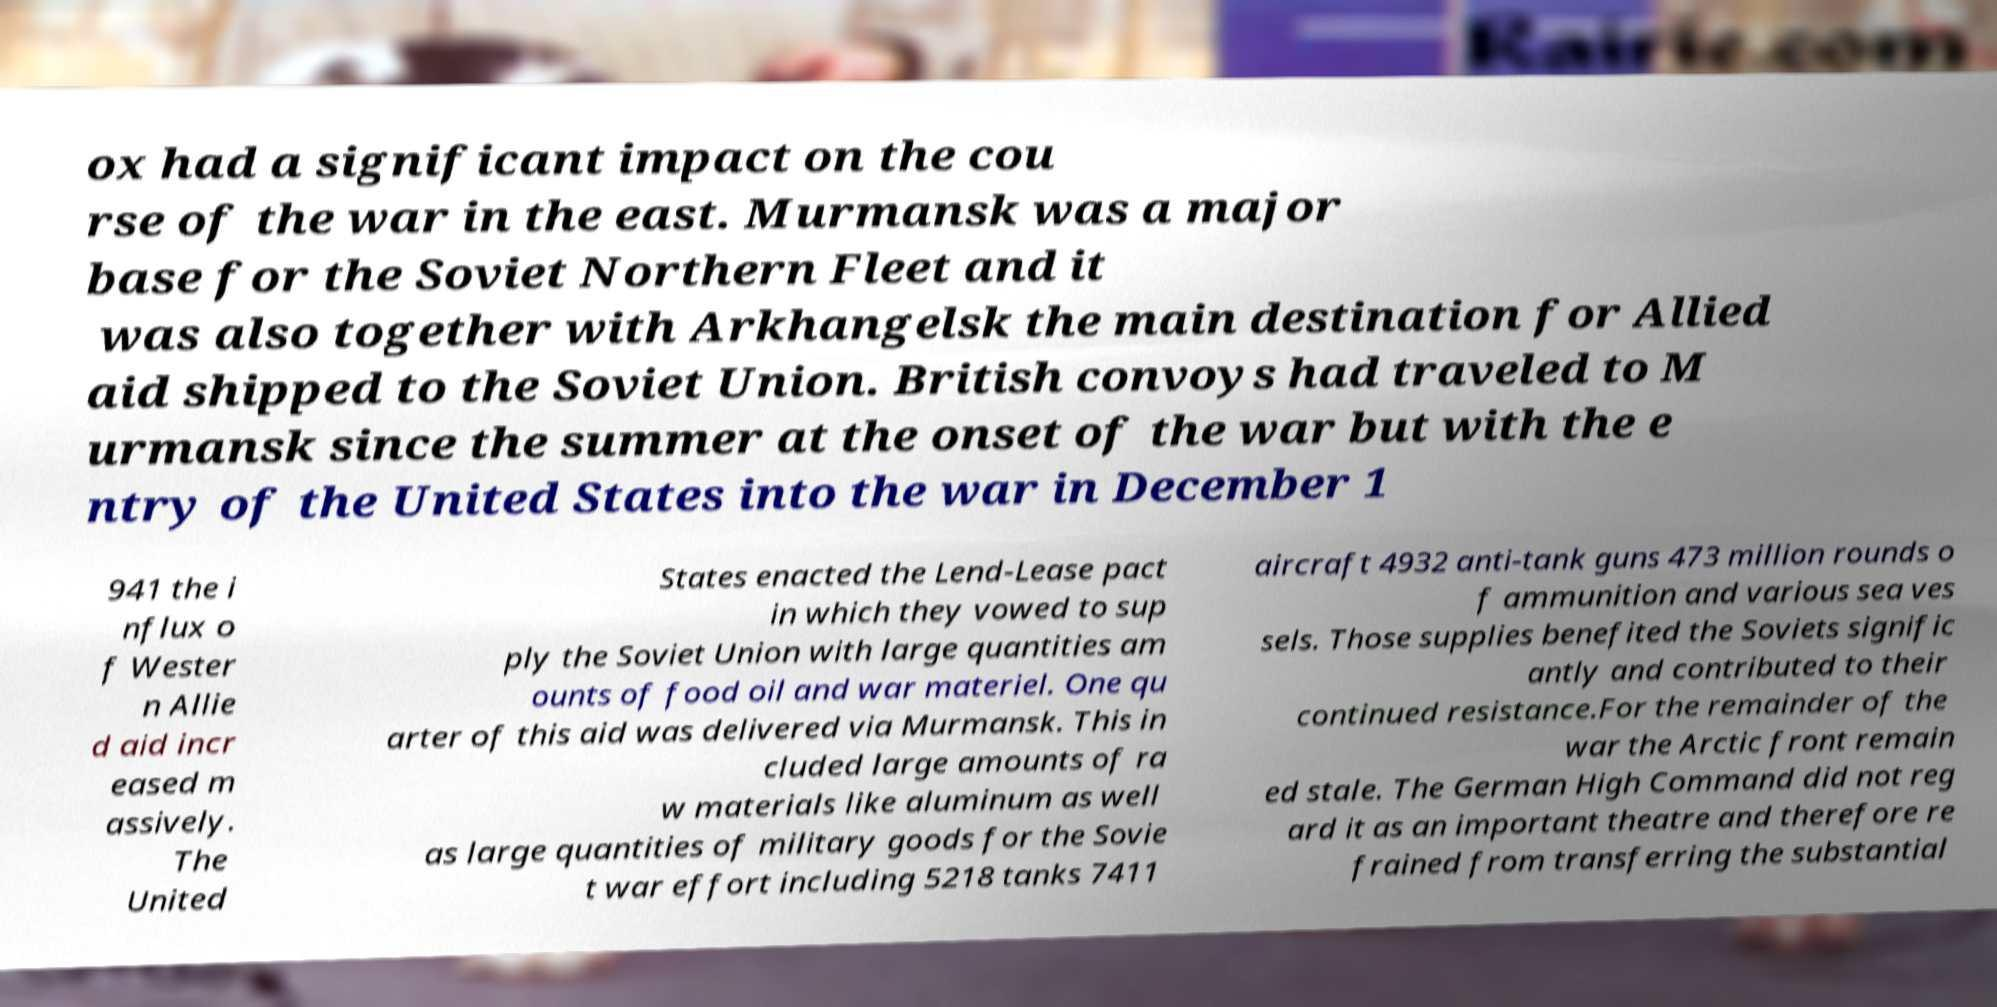There's text embedded in this image that I need extracted. Can you transcribe it verbatim? ox had a significant impact on the cou rse of the war in the east. Murmansk was a major base for the Soviet Northern Fleet and it was also together with Arkhangelsk the main destination for Allied aid shipped to the Soviet Union. British convoys had traveled to M urmansk since the summer at the onset of the war but with the e ntry of the United States into the war in December 1 941 the i nflux o f Wester n Allie d aid incr eased m assively. The United States enacted the Lend-Lease pact in which they vowed to sup ply the Soviet Union with large quantities am ounts of food oil and war materiel. One qu arter of this aid was delivered via Murmansk. This in cluded large amounts of ra w materials like aluminum as well as large quantities of military goods for the Sovie t war effort including 5218 tanks 7411 aircraft 4932 anti-tank guns 473 million rounds o f ammunition and various sea ves sels. Those supplies benefited the Soviets signific antly and contributed to their continued resistance.For the remainder of the war the Arctic front remain ed stale. The German High Command did not reg ard it as an important theatre and therefore re frained from transferring the substantial 